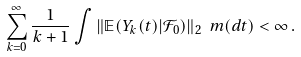Convert formula to latex. <formula><loc_0><loc_0><loc_500><loc_500>\sum _ { k = 0 } ^ { \infty } \frac { 1 } { k + 1 } \int \| { \mathbb { E } } ( Y _ { k } ( t ) | { \mathcal { F } } _ { 0 } ) \| _ { 2 } \ m ( d t ) < \infty \, .</formula> 